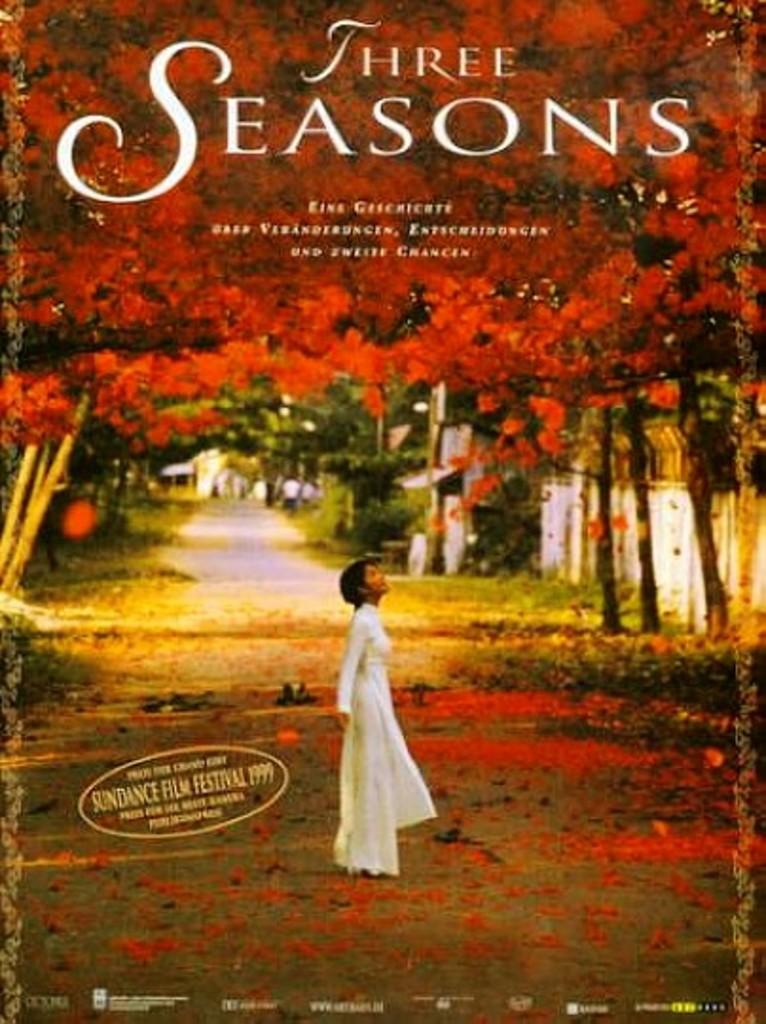What is the movie called?
Make the answer very short. Three seasons. What year is the sundance film festival?
Provide a succinct answer. 1999. 